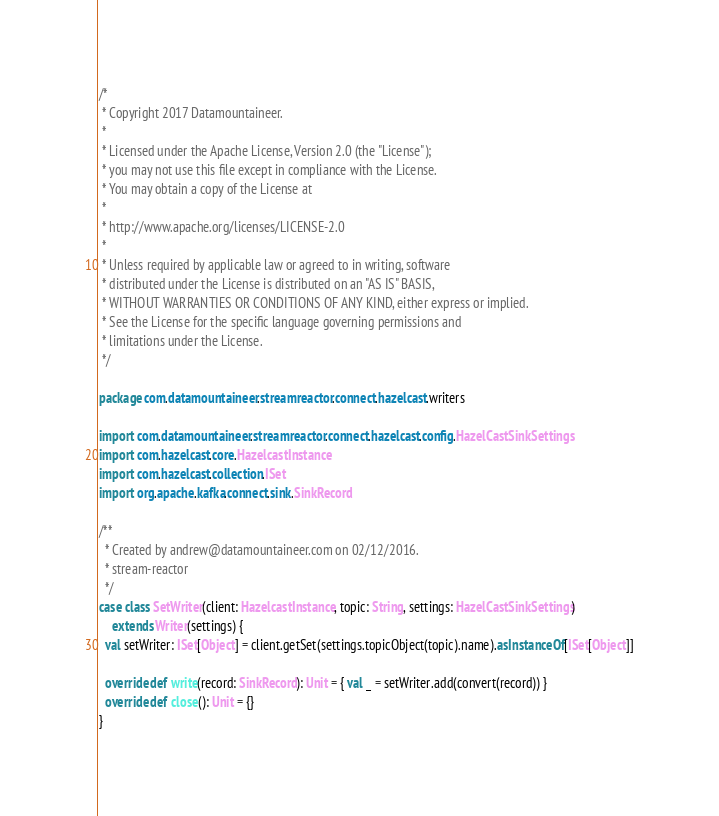Convert code to text. <code><loc_0><loc_0><loc_500><loc_500><_Scala_>/*
 * Copyright 2017 Datamountaineer.
 *
 * Licensed under the Apache License, Version 2.0 (the "License");
 * you may not use this file except in compliance with the License.
 * You may obtain a copy of the License at
 *
 * http://www.apache.org/licenses/LICENSE-2.0
 *
 * Unless required by applicable law or agreed to in writing, software
 * distributed under the License is distributed on an "AS IS" BASIS,
 * WITHOUT WARRANTIES OR CONDITIONS OF ANY KIND, either express or implied.
 * See the License for the specific language governing permissions and
 * limitations under the License.
 */

package com.datamountaineer.streamreactor.connect.hazelcast.writers

import com.datamountaineer.streamreactor.connect.hazelcast.config.HazelCastSinkSettings
import com.hazelcast.core.HazelcastInstance
import com.hazelcast.collection.ISet
import org.apache.kafka.connect.sink.SinkRecord

/**
  * Created by andrew@datamountaineer.com on 02/12/2016.
  * stream-reactor
  */
case class SetWriter(client: HazelcastInstance, topic: String, settings: HazelCastSinkSettings)
    extends Writer(settings) {
  val setWriter: ISet[Object] = client.getSet(settings.topicObject(topic).name).asInstanceOf[ISet[Object]]

  override def write(record: SinkRecord): Unit = { val _ = setWriter.add(convert(record)) }
  override def close(): Unit = {}
}
</code> 